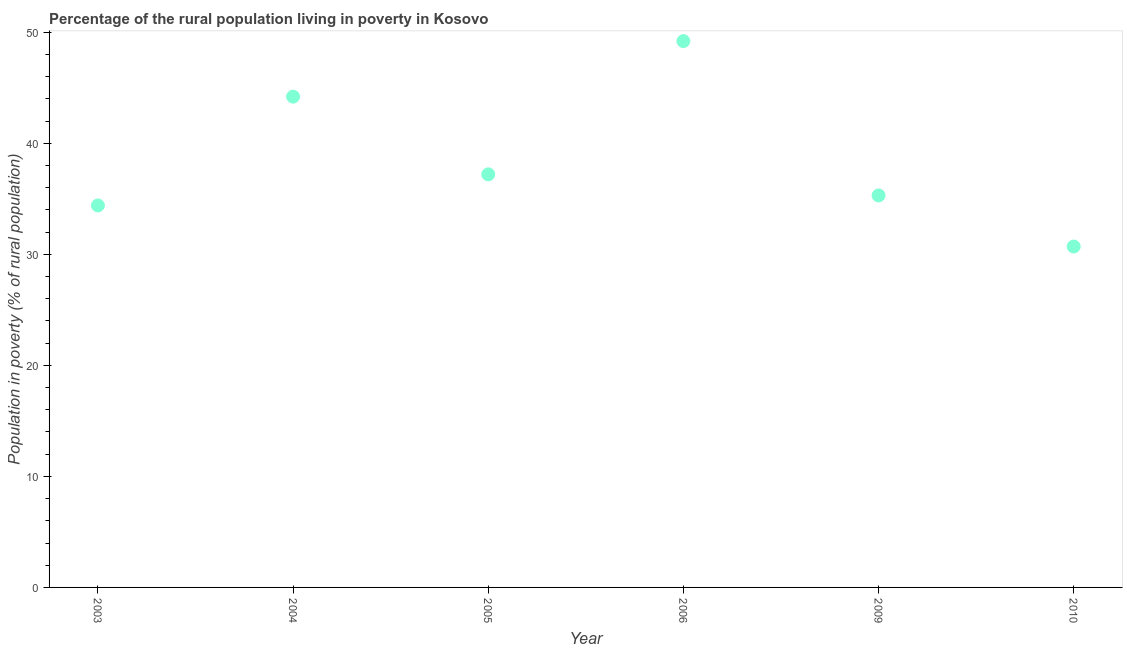What is the percentage of rural population living below poverty line in 2004?
Ensure brevity in your answer.  44.2. Across all years, what is the maximum percentage of rural population living below poverty line?
Your answer should be compact. 49.2. Across all years, what is the minimum percentage of rural population living below poverty line?
Offer a terse response. 30.7. What is the sum of the percentage of rural population living below poverty line?
Provide a short and direct response. 231. What is the difference between the percentage of rural population living below poverty line in 2003 and 2004?
Your answer should be compact. -9.8. What is the average percentage of rural population living below poverty line per year?
Keep it short and to the point. 38.5. What is the median percentage of rural population living below poverty line?
Offer a terse response. 36.25. Do a majority of the years between 2006 and 2004 (inclusive) have percentage of rural population living below poverty line greater than 10 %?
Your response must be concise. No. What is the ratio of the percentage of rural population living below poverty line in 2003 to that in 2006?
Ensure brevity in your answer.  0.7. Is the percentage of rural population living below poverty line in 2004 less than that in 2010?
Your answer should be very brief. No. What is the difference between the highest and the lowest percentage of rural population living below poverty line?
Provide a succinct answer. 18.5. In how many years, is the percentage of rural population living below poverty line greater than the average percentage of rural population living below poverty line taken over all years?
Make the answer very short. 2. How many years are there in the graph?
Keep it short and to the point. 6. Does the graph contain any zero values?
Give a very brief answer. No. Does the graph contain grids?
Your answer should be very brief. No. What is the title of the graph?
Keep it short and to the point. Percentage of the rural population living in poverty in Kosovo. What is the label or title of the Y-axis?
Give a very brief answer. Population in poverty (% of rural population). What is the Population in poverty (% of rural population) in 2003?
Your answer should be compact. 34.4. What is the Population in poverty (% of rural population) in 2004?
Offer a very short reply. 44.2. What is the Population in poverty (% of rural population) in 2005?
Ensure brevity in your answer.  37.2. What is the Population in poverty (% of rural population) in 2006?
Your answer should be very brief. 49.2. What is the Population in poverty (% of rural population) in 2009?
Give a very brief answer. 35.3. What is the Population in poverty (% of rural population) in 2010?
Provide a succinct answer. 30.7. What is the difference between the Population in poverty (% of rural population) in 2003 and 2006?
Your response must be concise. -14.8. What is the difference between the Population in poverty (% of rural population) in 2004 and 2005?
Provide a short and direct response. 7. What is the difference between the Population in poverty (% of rural population) in 2004 and 2010?
Offer a very short reply. 13.5. What is the difference between the Population in poverty (% of rural population) in 2005 and 2010?
Your response must be concise. 6.5. What is the difference between the Population in poverty (% of rural population) in 2006 and 2010?
Offer a terse response. 18.5. What is the ratio of the Population in poverty (% of rural population) in 2003 to that in 2004?
Keep it short and to the point. 0.78. What is the ratio of the Population in poverty (% of rural population) in 2003 to that in 2005?
Provide a short and direct response. 0.93. What is the ratio of the Population in poverty (% of rural population) in 2003 to that in 2006?
Your answer should be very brief. 0.7. What is the ratio of the Population in poverty (% of rural population) in 2003 to that in 2009?
Provide a succinct answer. 0.97. What is the ratio of the Population in poverty (% of rural population) in 2003 to that in 2010?
Keep it short and to the point. 1.12. What is the ratio of the Population in poverty (% of rural population) in 2004 to that in 2005?
Provide a succinct answer. 1.19. What is the ratio of the Population in poverty (% of rural population) in 2004 to that in 2006?
Ensure brevity in your answer.  0.9. What is the ratio of the Population in poverty (% of rural population) in 2004 to that in 2009?
Keep it short and to the point. 1.25. What is the ratio of the Population in poverty (% of rural population) in 2004 to that in 2010?
Your answer should be compact. 1.44. What is the ratio of the Population in poverty (% of rural population) in 2005 to that in 2006?
Provide a succinct answer. 0.76. What is the ratio of the Population in poverty (% of rural population) in 2005 to that in 2009?
Your answer should be compact. 1.05. What is the ratio of the Population in poverty (% of rural population) in 2005 to that in 2010?
Ensure brevity in your answer.  1.21. What is the ratio of the Population in poverty (% of rural population) in 2006 to that in 2009?
Provide a short and direct response. 1.39. What is the ratio of the Population in poverty (% of rural population) in 2006 to that in 2010?
Your answer should be compact. 1.6. What is the ratio of the Population in poverty (% of rural population) in 2009 to that in 2010?
Offer a terse response. 1.15. 